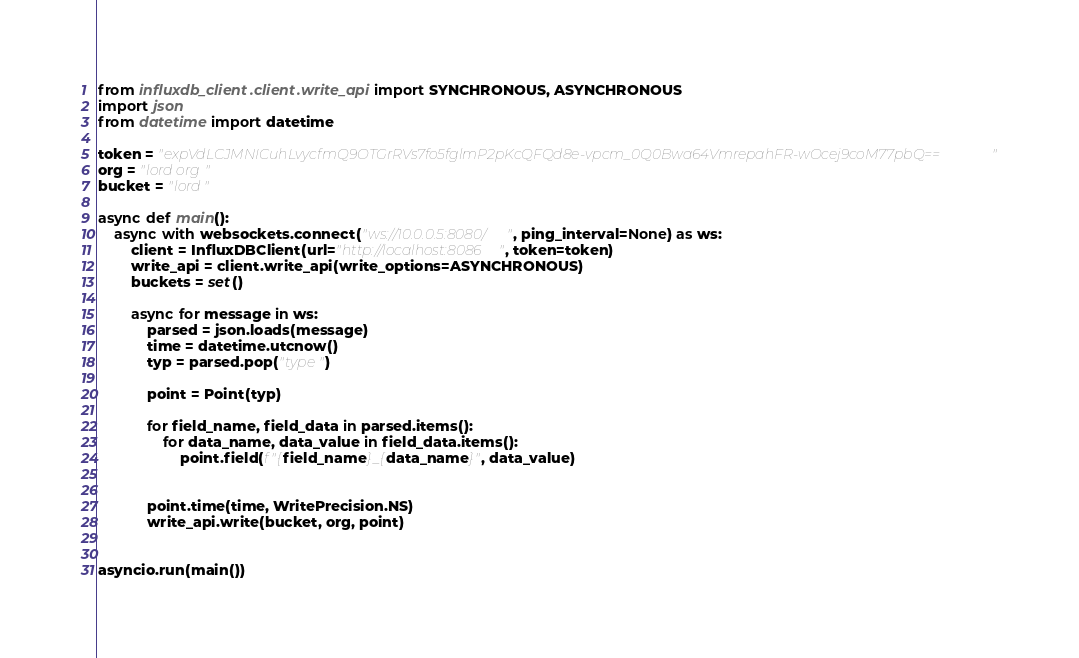<code> <loc_0><loc_0><loc_500><loc_500><_Python_>from influxdb_client.client.write_api import SYNCHRONOUS, ASYNCHRONOUS
import json
from datetime import datetime

token = "expVdLCJMNICuhLvycfmQ9OTGrRVs7fo5fglmP2pKcQFQd8e-vpcm_0Q0Bwa64VmrepahFR-wOcej9coM77pbQ=="
org = "lord org"
bucket = "lord"

async def main():
    async with websockets.connect("ws://10.0.0.5:8080/", ping_interval=None) as ws:
        client = InfluxDBClient(url="http://localhost:8086", token=token)
        write_api = client.write_api(write_options=ASYNCHRONOUS)
        buckets = set()

        async for message in ws:
            parsed = json.loads(message)
            time = datetime.utcnow()
            typ = parsed.pop("type")

            point = Point(typ)

            for field_name, field_data in parsed.items():
                for data_name, data_value in field_data.items():
                    point.field(f"{field_name}_{data_name}", data_value)


            point.time(time, WritePrecision.NS)
            write_api.write(bucket, org, point)


asyncio.run(main())
</code> 